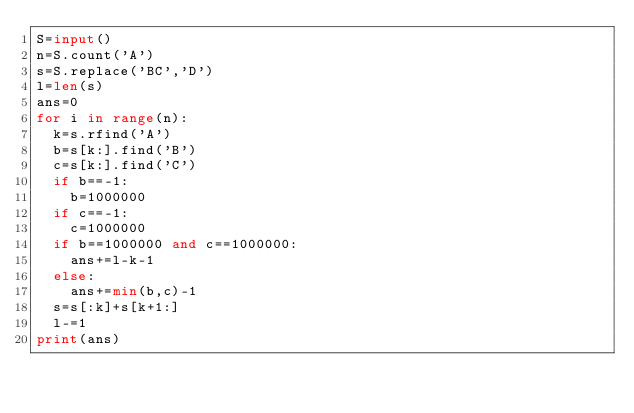Convert code to text. <code><loc_0><loc_0><loc_500><loc_500><_Python_>S=input()
n=S.count('A')
s=S.replace('BC','D')
l=len(s)
ans=0
for i in range(n):
  k=s.rfind('A')
  b=s[k:].find('B')
  c=s[k:].find('C')
  if b==-1:
    b=1000000
  if c==-1:
    c=1000000
  if b==1000000 and c==1000000:
    ans+=l-k-1
  else:
    ans+=min(b,c)-1
  s=s[:k]+s[k+1:]
  l-=1
print(ans)</code> 